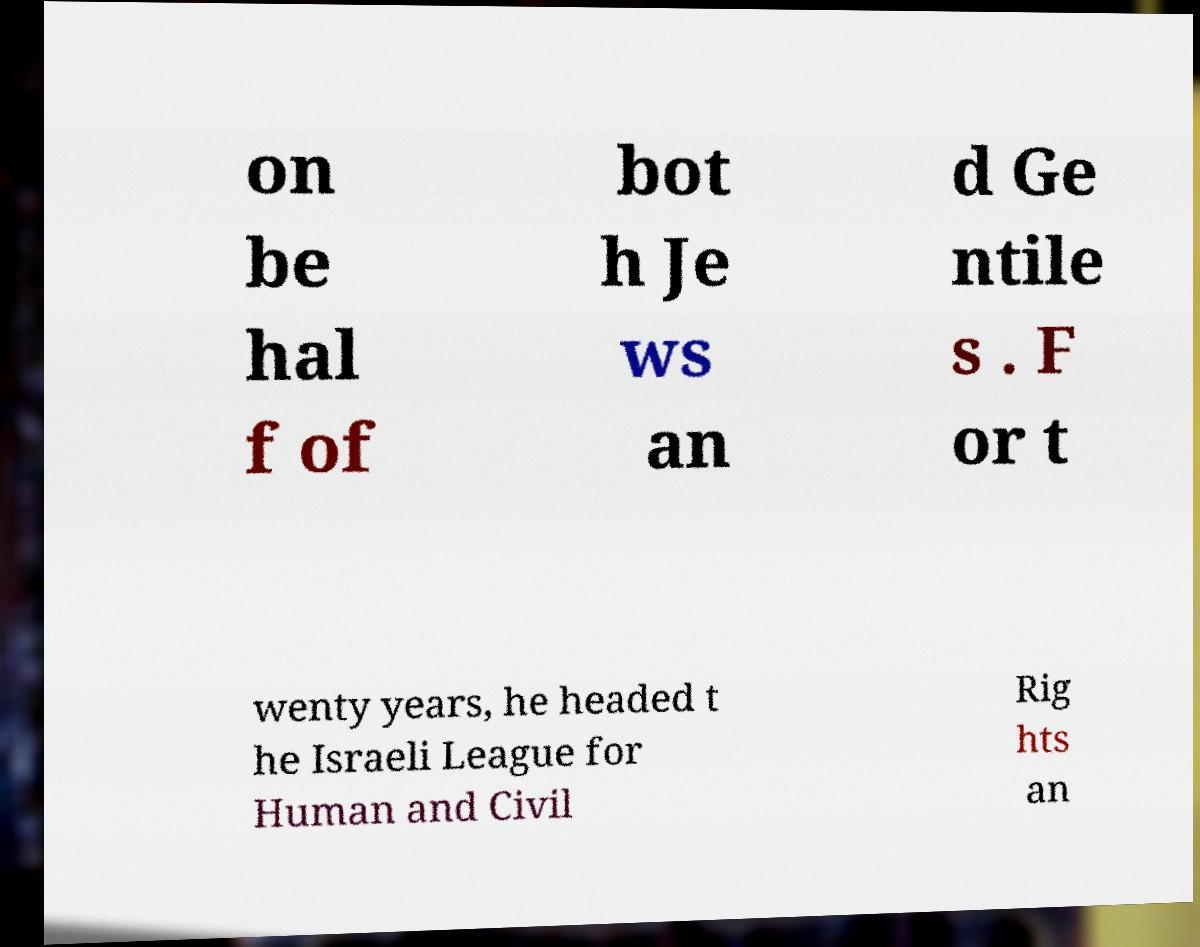I need the written content from this picture converted into text. Can you do that? on be hal f of bot h Je ws an d Ge ntile s . F or t wenty years, he headed t he Israeli League for Human and Civil Rig hts an 